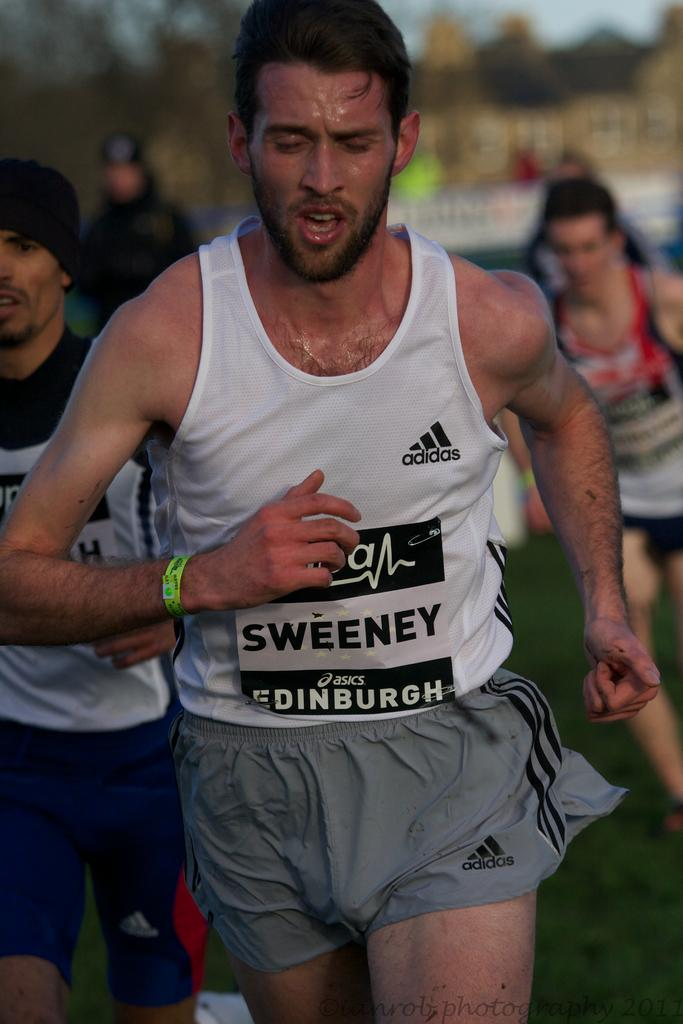<image>
Provide a brief description of the given image. A man is jogging, wearing a sign reading Sweeney. 